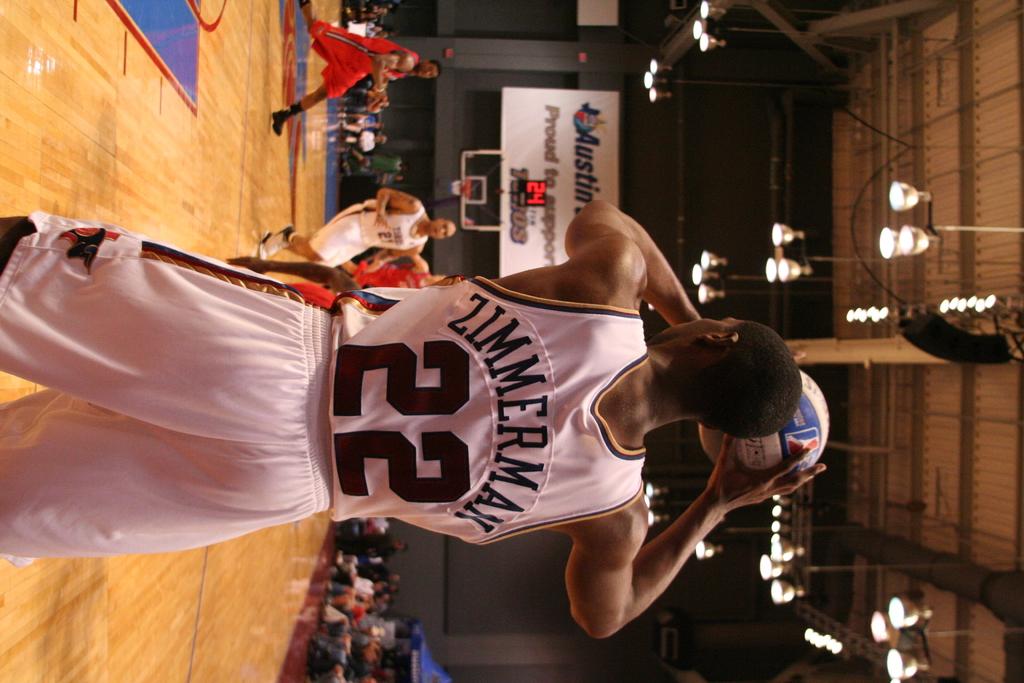Which player is that?
Give a very brief answer. Zimmerman. What is players number with the ball?
Provide a succinct answer. 22. 